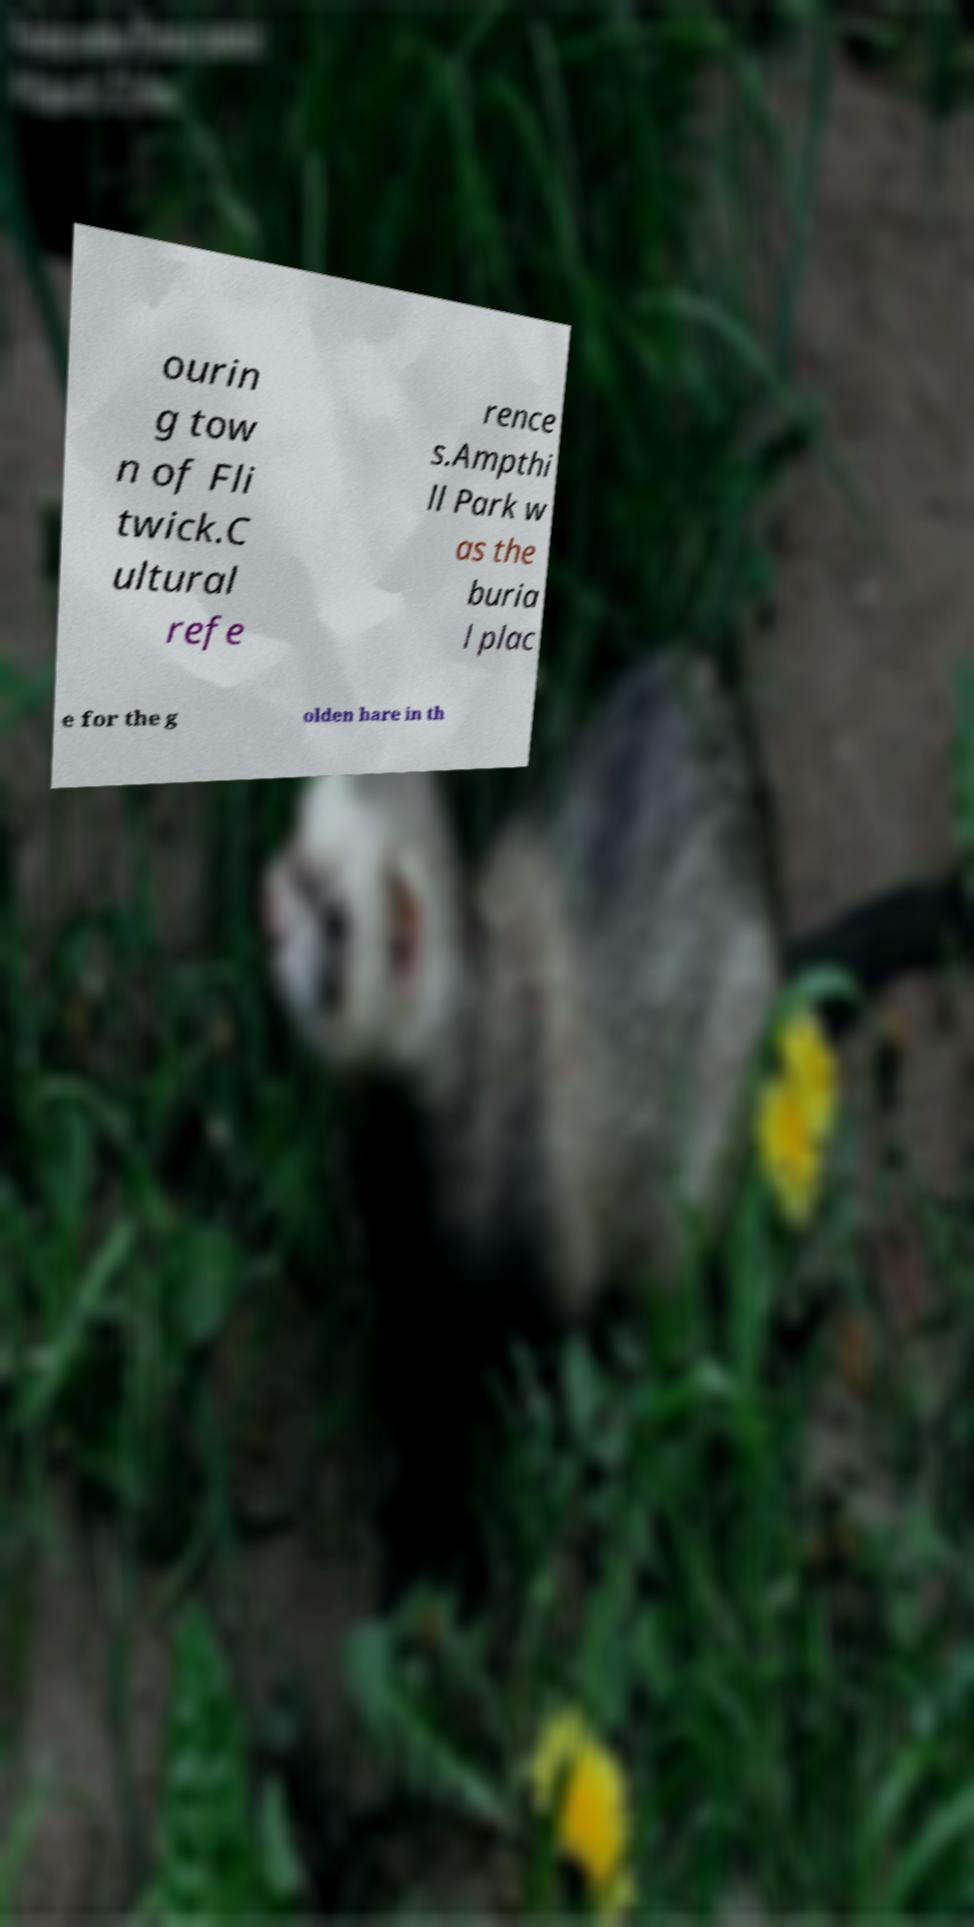I need the written content from this picture converted into text. Can you do that? ourin g tow n of Fli twick.C ultural refe rence s.Ampthi ll Park w as the buria l plac e for the g olden hare in th 